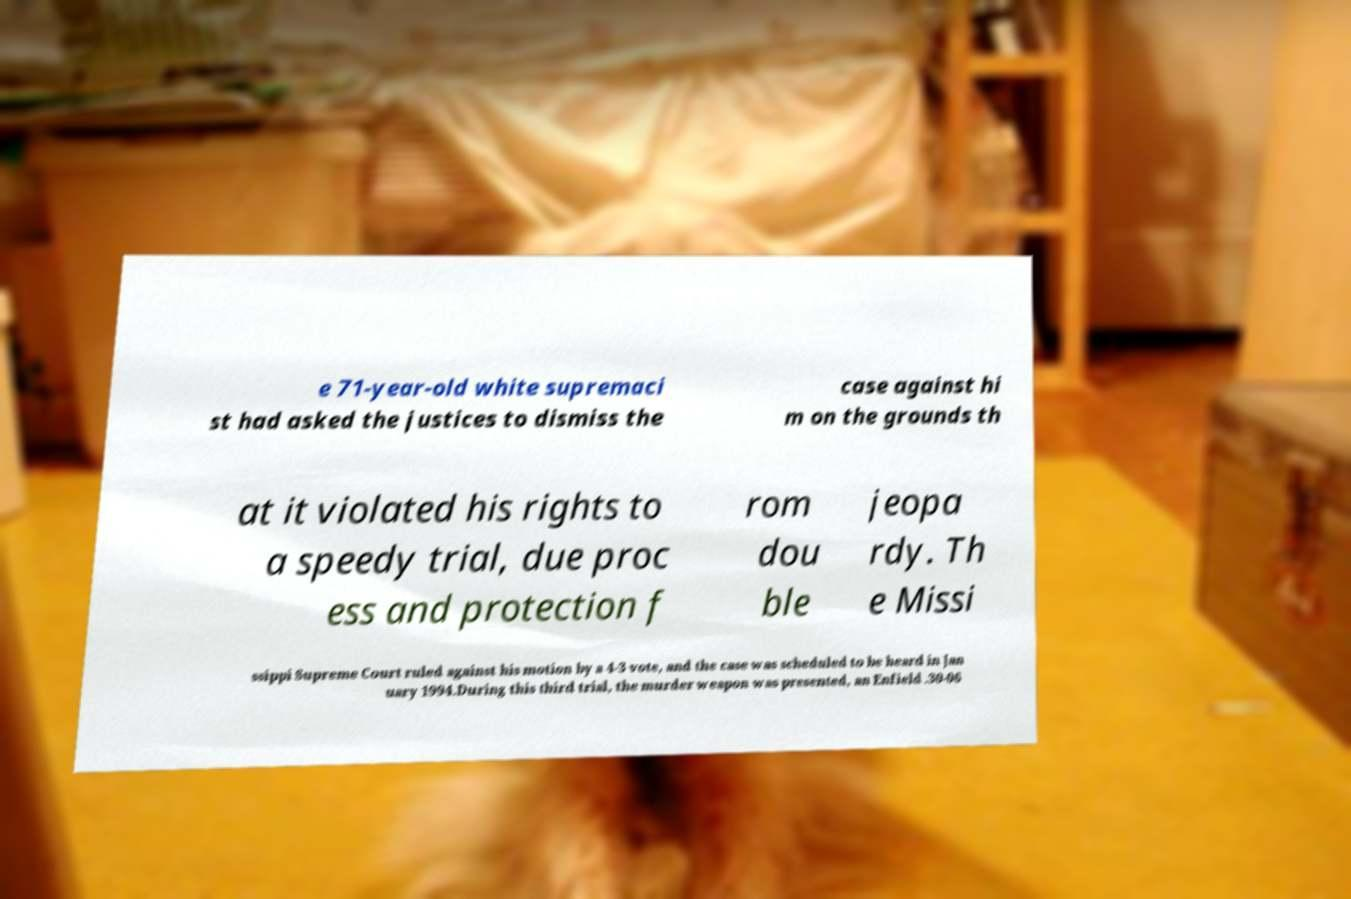There's text embedded in this image that I need extracted. Can you transcribe it verbatim? e 71-year-old white supremaci st had asked the justices to dismiss the case against hi m on the grounds th at it violated his rights to a speedy trial, due proc ess and protection f rom dou ble jeopa rdy. Th e Missi ssippi Supreme Court ruled against his motion by a 4-3 vote, and the case was scheduled to be heard in Jan uary 1994.During this third trial, the murder weapon was presented, an Enfield .30-06 